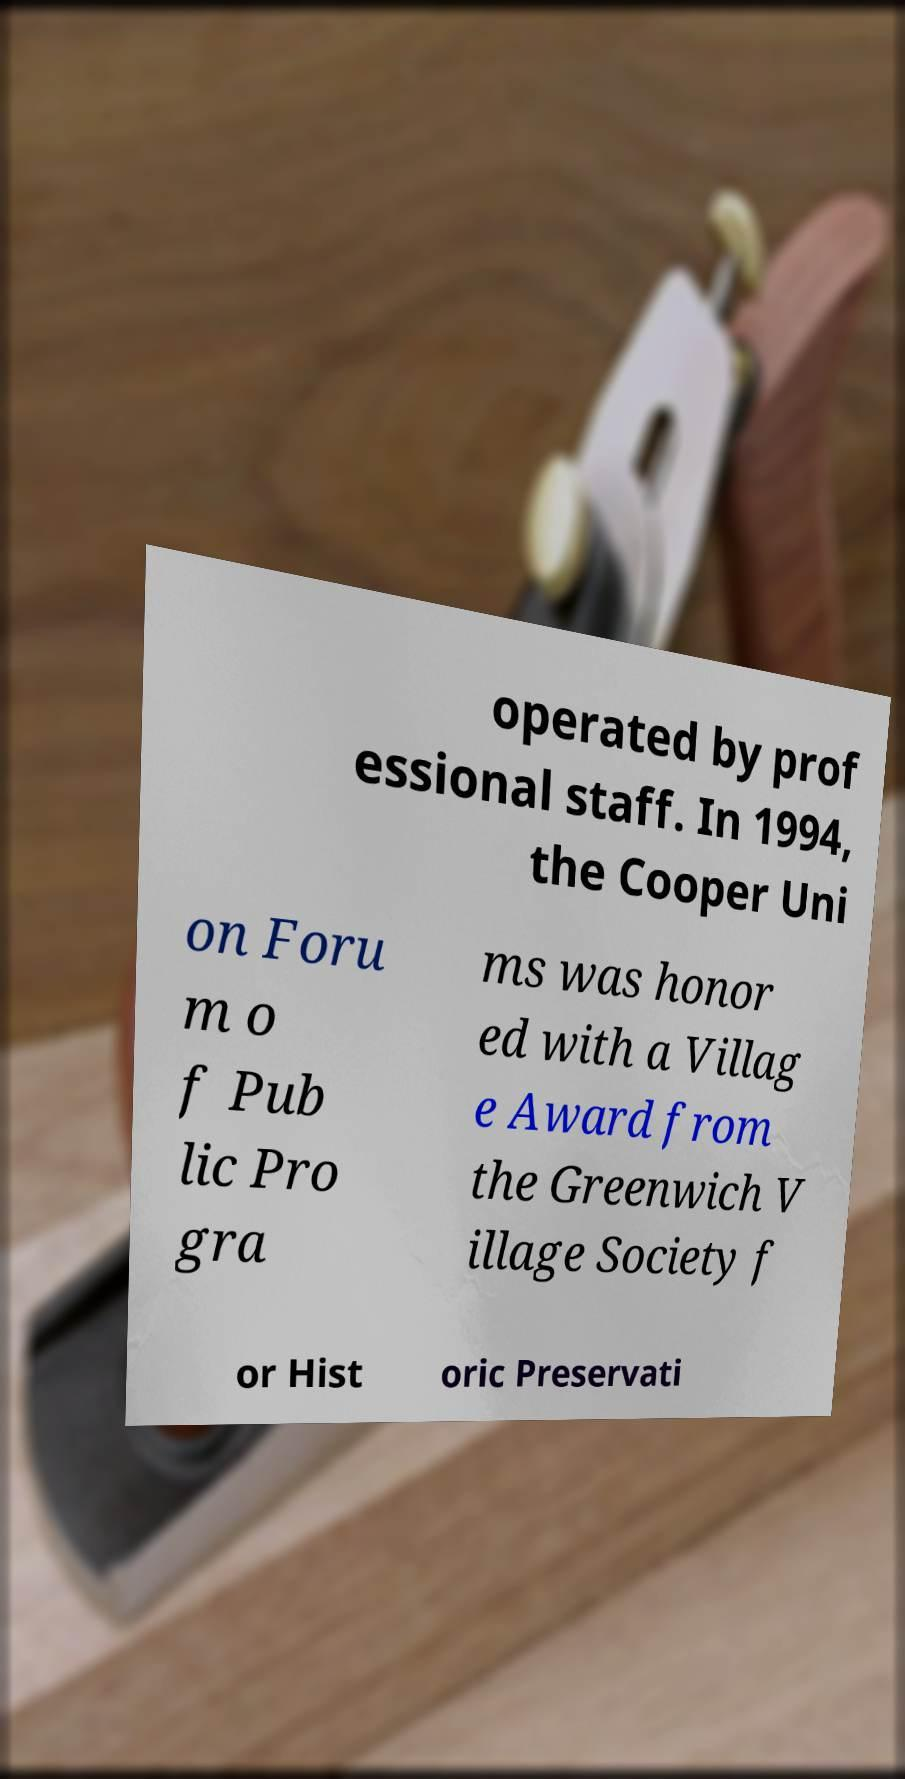I need the written content from this picture converted into text. Can you do that? operated by prof essional staff. In 1994, the Cooper Uni on Foru m o f Pub lic Pro gra ms was honor ed with a Villag e Award from the Greenwich V illage Society f or Hist oric Preservati 